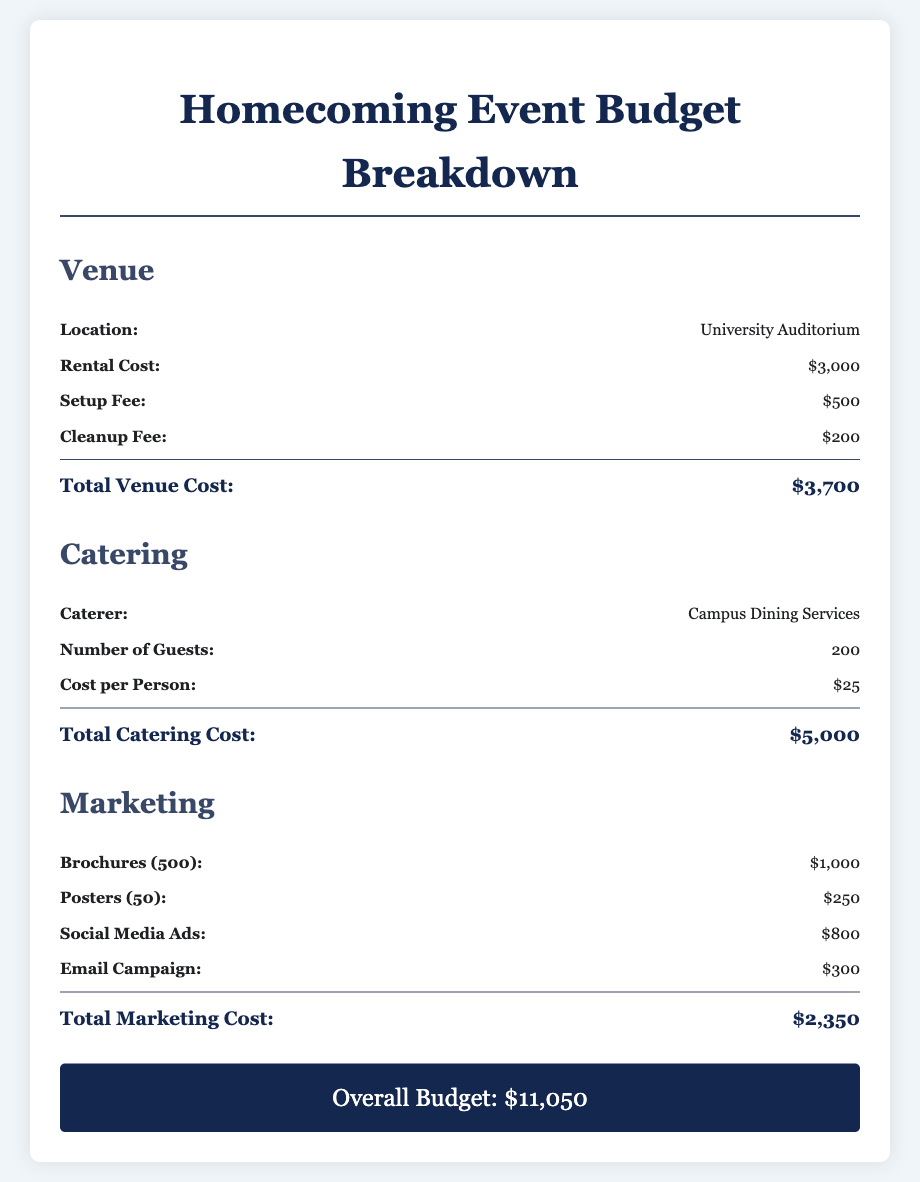What is the location of the event? The document specifies that the location of the event is the University Auditorium.
Answer: University Auditorium What is the rental cost for the venue? The rental cost for the venue is listed as $3,000.
Answer: $3,000 How many guests are expected for catering? The document indicates that there will be 200 guests for catering.
Answer: 200 What is the cost per person for catering? The cost per person for catering is stated as $25.
Answer: $25 What is the total catering cost? The total catering cost is provided as $5,000, calculated based on the number of guests and cost per person.
Answer: $5,000 How much is allocated for brochures in marketing? The document states that brochures cost $1,000.
Answer: $1,000 What is the total marketing cost? The total marketing cost is given as $2,350, which is the sum of all marketing expenses listed.
Answer: $2,350 What is the overall budget for the homecoming event? The document provides the overall budget as the total of venue, catering, and marketing costs, totaling $11,050.
Answer: $11,050 How much is the cleanup fee for the venue? The cleanup fee for the venue is mentioned as $200.
Answer: $200 